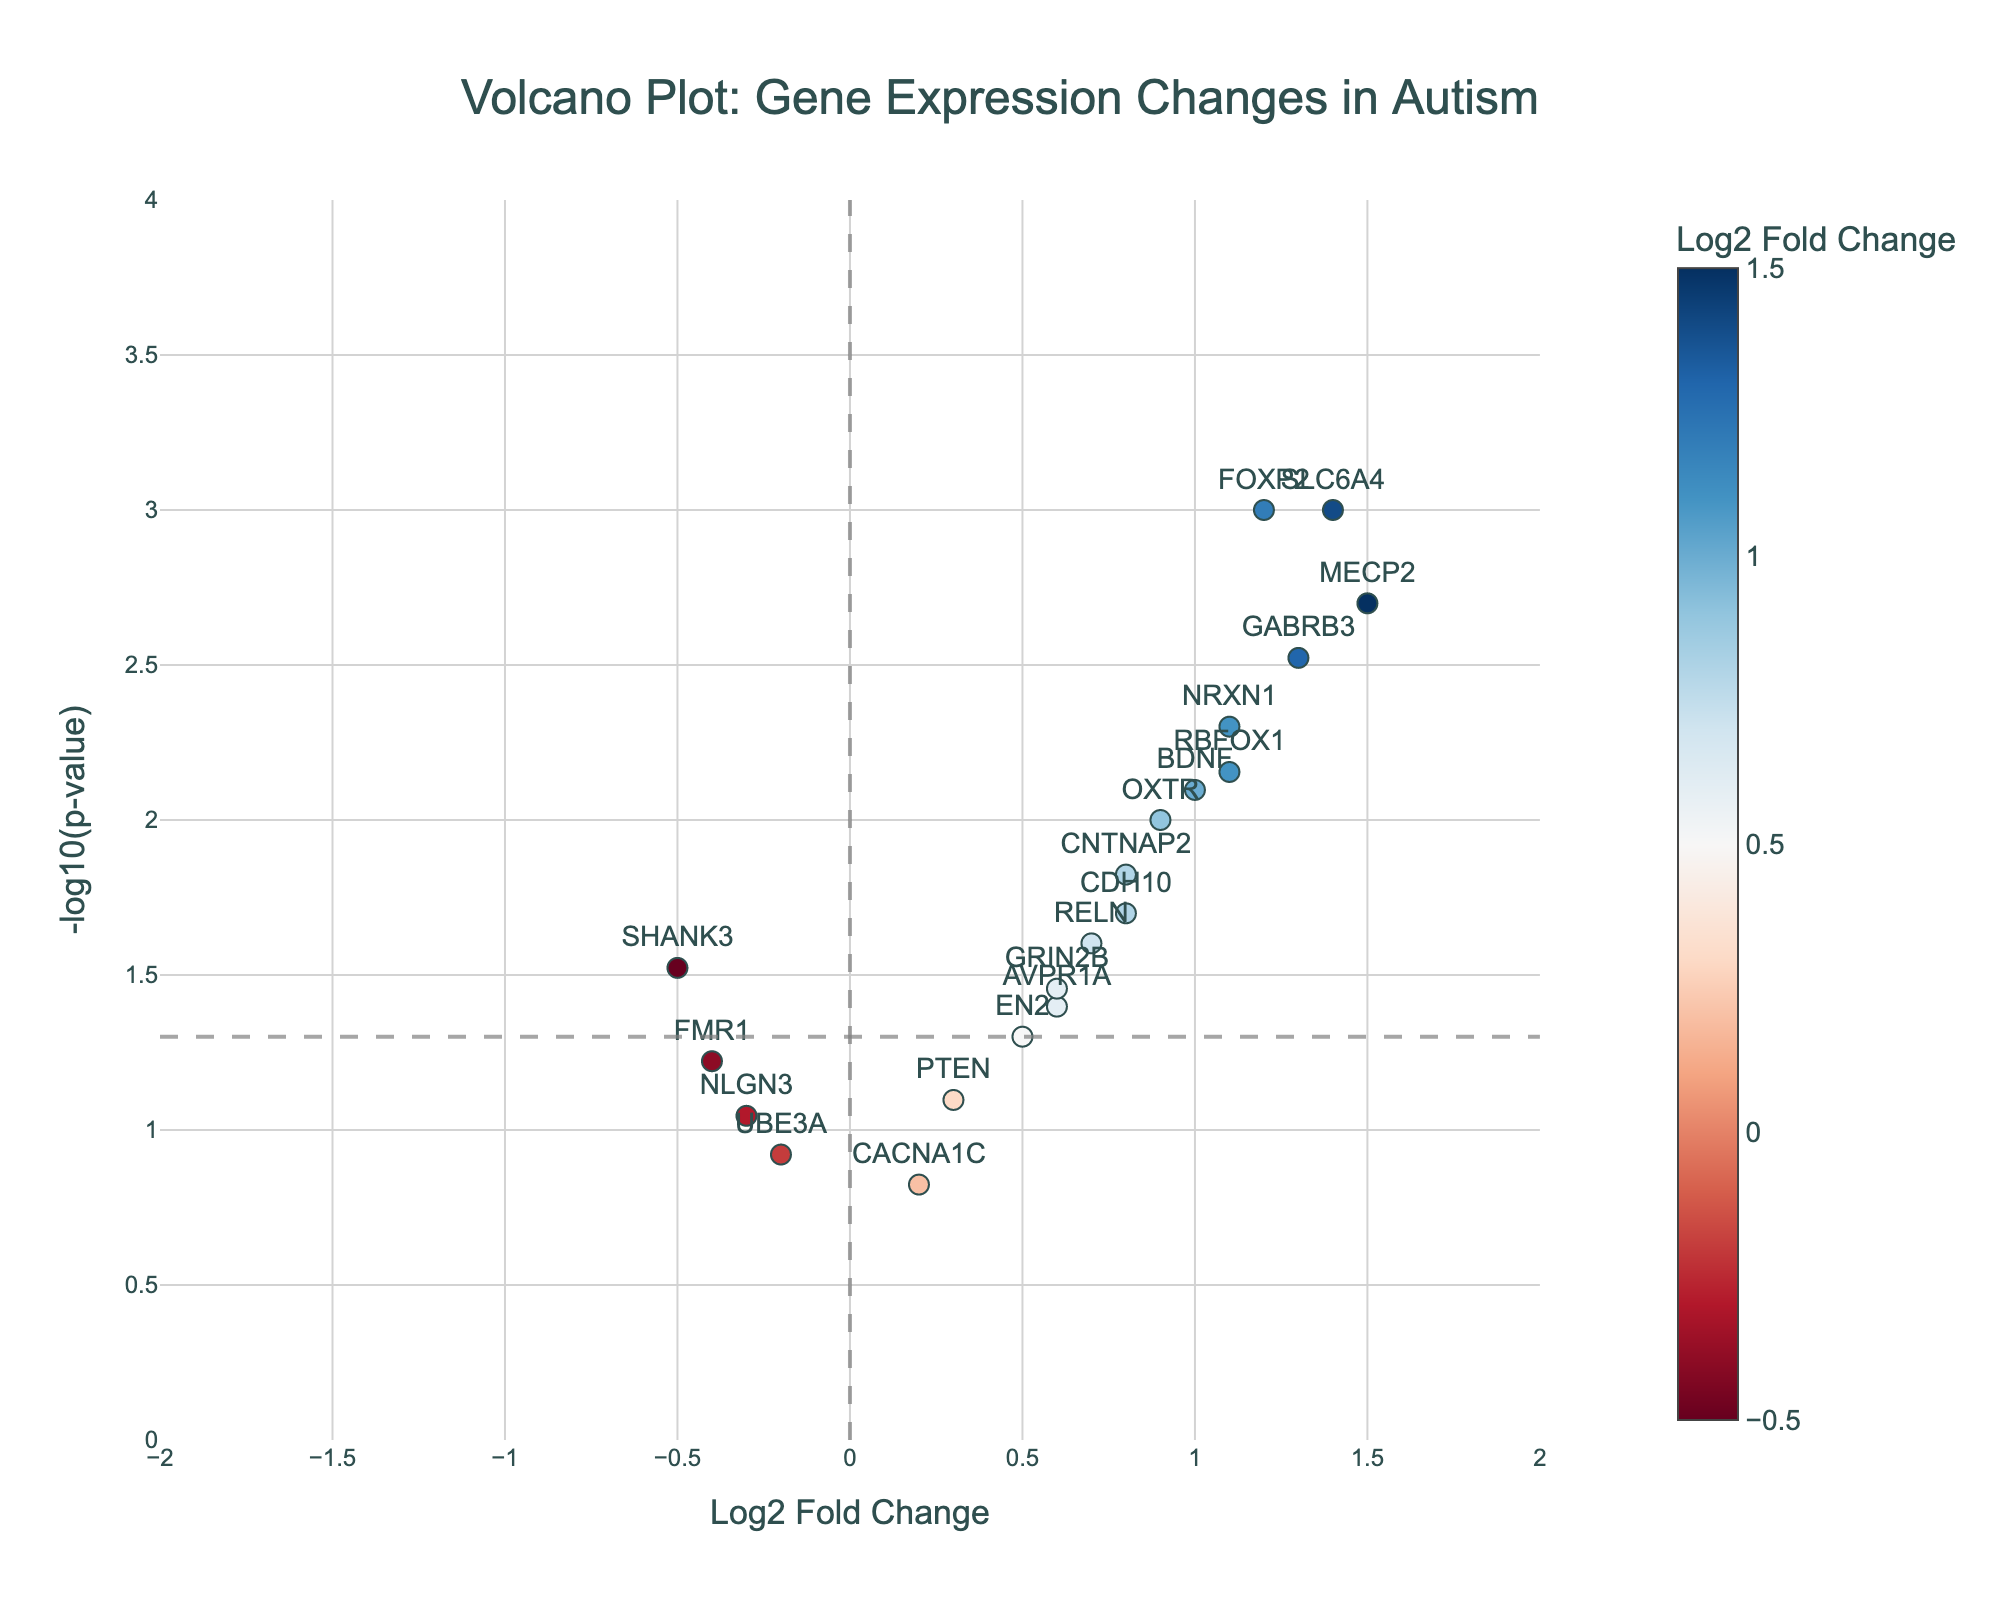How many genes show significant changes in expression? Count the number of genes above the horizontal line (y = -log10(0.05)) representing p-value significance. There are 13 points above this threshold.
Answer: 13 Which gene has the highest fold change? Look at the x-axis for the furthest positive point. MECP2 has the highest fold change with a Log2FoldChange of 1.5.
Answer: MECP2 What is the fold change of the gene with the lowest p-value? Identify the gene with the highest y-value. FOXP2 has the lowest p-value (highest y-value) and a Log2FoldChange of 1.2.
Answer: 1.2 Are there any genes with negative fold changes and significant p-values? Check the left side of the vertical line (x=0) for points above the horizontal line (y=-log10(0.05)). SHANK3 and UBE3A have negative fold changes but only SHANK3 is significant as it's above the threshold.
Answer: SHANK3 Which gene is closest to the significance threshold (p=0.05)? Find the point nearest to the horizontal line y=-log10(0.05) on both y-axes. AVPR1A is closest with a slightly higher y value than 1.3
Answer: AVPR1A Do any genes have fold changes between -0.5 and 0.5 and significant p-values? Look between -0.5 and 0.5 on the x-axis and check if any points are above the threshold. SHANK3 is located within this range and has significant p-values.
Answer: SHANK3 Which two genes have the closest fold change values? Visually compare the x-coordinates. CNTNAP2 and CDH10 both have a Log2FoldChange of 0.8, making them the closest pair.
Answer: CNTNAP2 and CDH10 What is the average Log2 Fold Change value for genes with significant p-values? Sum the Log2FoldChange values of significant genes and divide by the number of significant genes (1.2+0.8-0.5+1.5+1.1+0.9+0.6+1.3+0.7+1.0+1.4+0.6+0.8)/13 ≈ 0.885
Answer: 0.885 Which gene has the highest Log2 Fold Change but is not statistically significant? Look for the point with the highest x value, not above the threshold. CACNA1C has the highest non-significant Log2FoldChange of 0.2.
Answer: CACNA1C What colors represent upregulated and downregulated genes? Identify the color bar and its associated scale. Positive (upregulated) to red, negative (downregulated) towards blue.
Answer: Upregulated-red, Downregulated-blue 